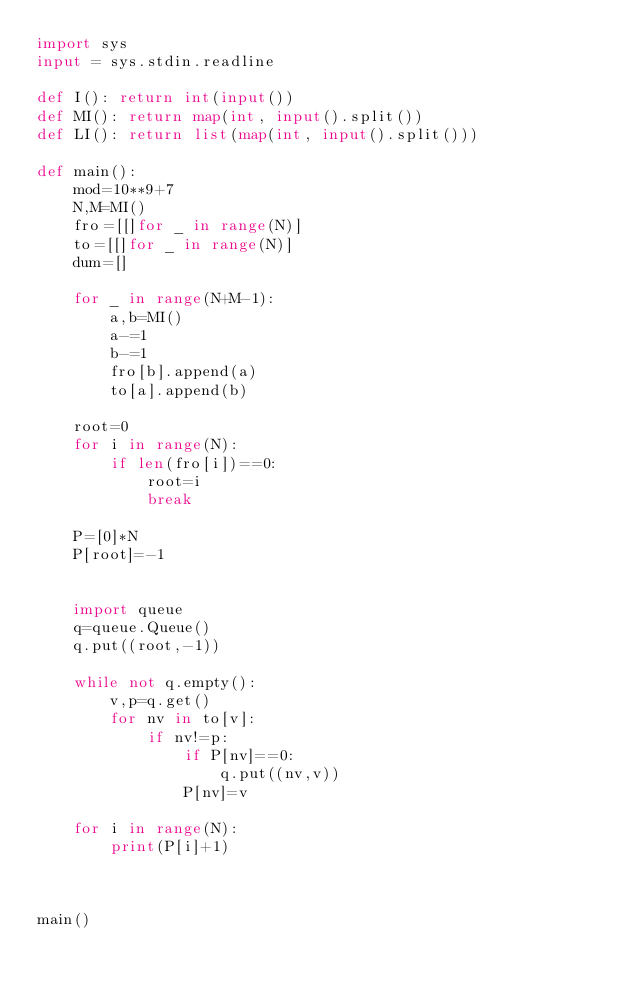<code> <loc_0><loc_0><loc_500><loc_500><_Python_>import sys
input = sys.stdin.readline

def I(): return int(input())
def MI(): return map(int, input().split())
def LI(): return list(map(int, input().split()))

def main():
    mod=10**9+7
    N,M=MI()
    fro=[[]for _ in range(N)]
    to=[[]for _ in range(N)]
    dum=[]
    
    for _ in range(N+M-1):
        a,b=MI()
        a-=1
        b-=1
        fro[b].append(a)
        to[a].append(b)
        
    root=0
    for i in range(N):
        if len(fro[i])==0:
            root=i
            break
        
    P=[0]*N
    P[root]=-1
    
    
    import queue
    q=queue.Queue()
    q.put((root,-1))
    
    while not q.empty():
        v,p=q.get()
        for nv in to[v]:
            if nv!=p:
                if P[nv]==0:
                    q.put((nv,v))
                P[nv]=v
                
    for i in range(N):
        print(P[i]+1)
    
        

main()
</code> 